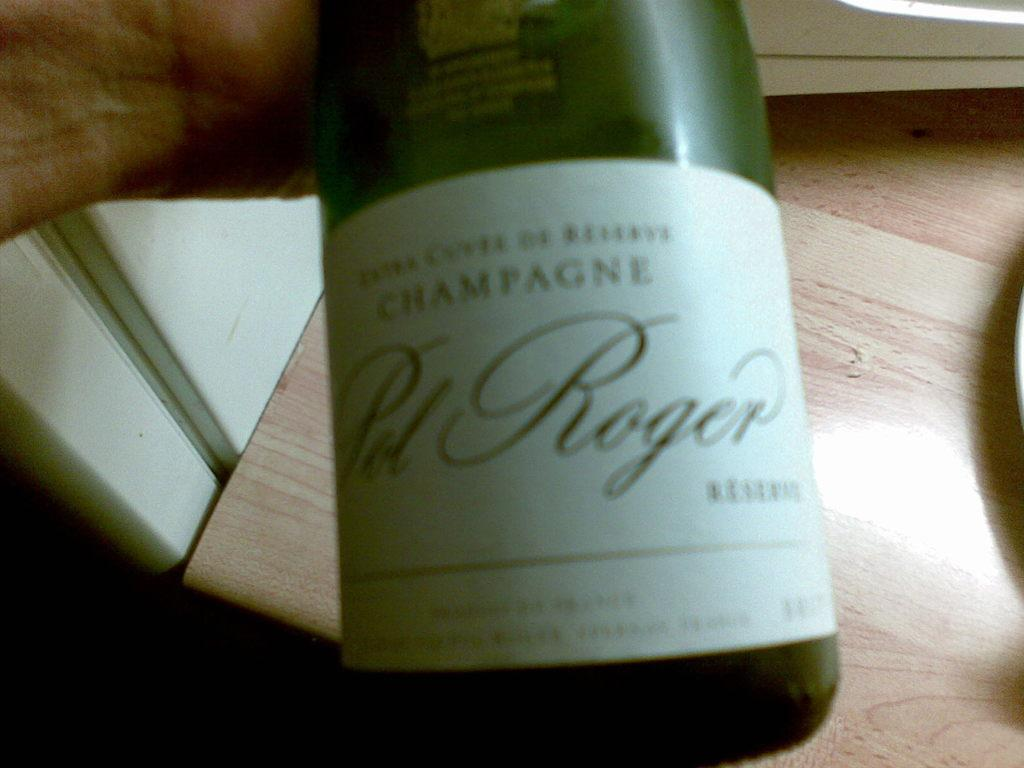<image>
Offer a succinct explanation of the picture presented. A person holding a bottle of Sol Roger champagne over a wood counter top 